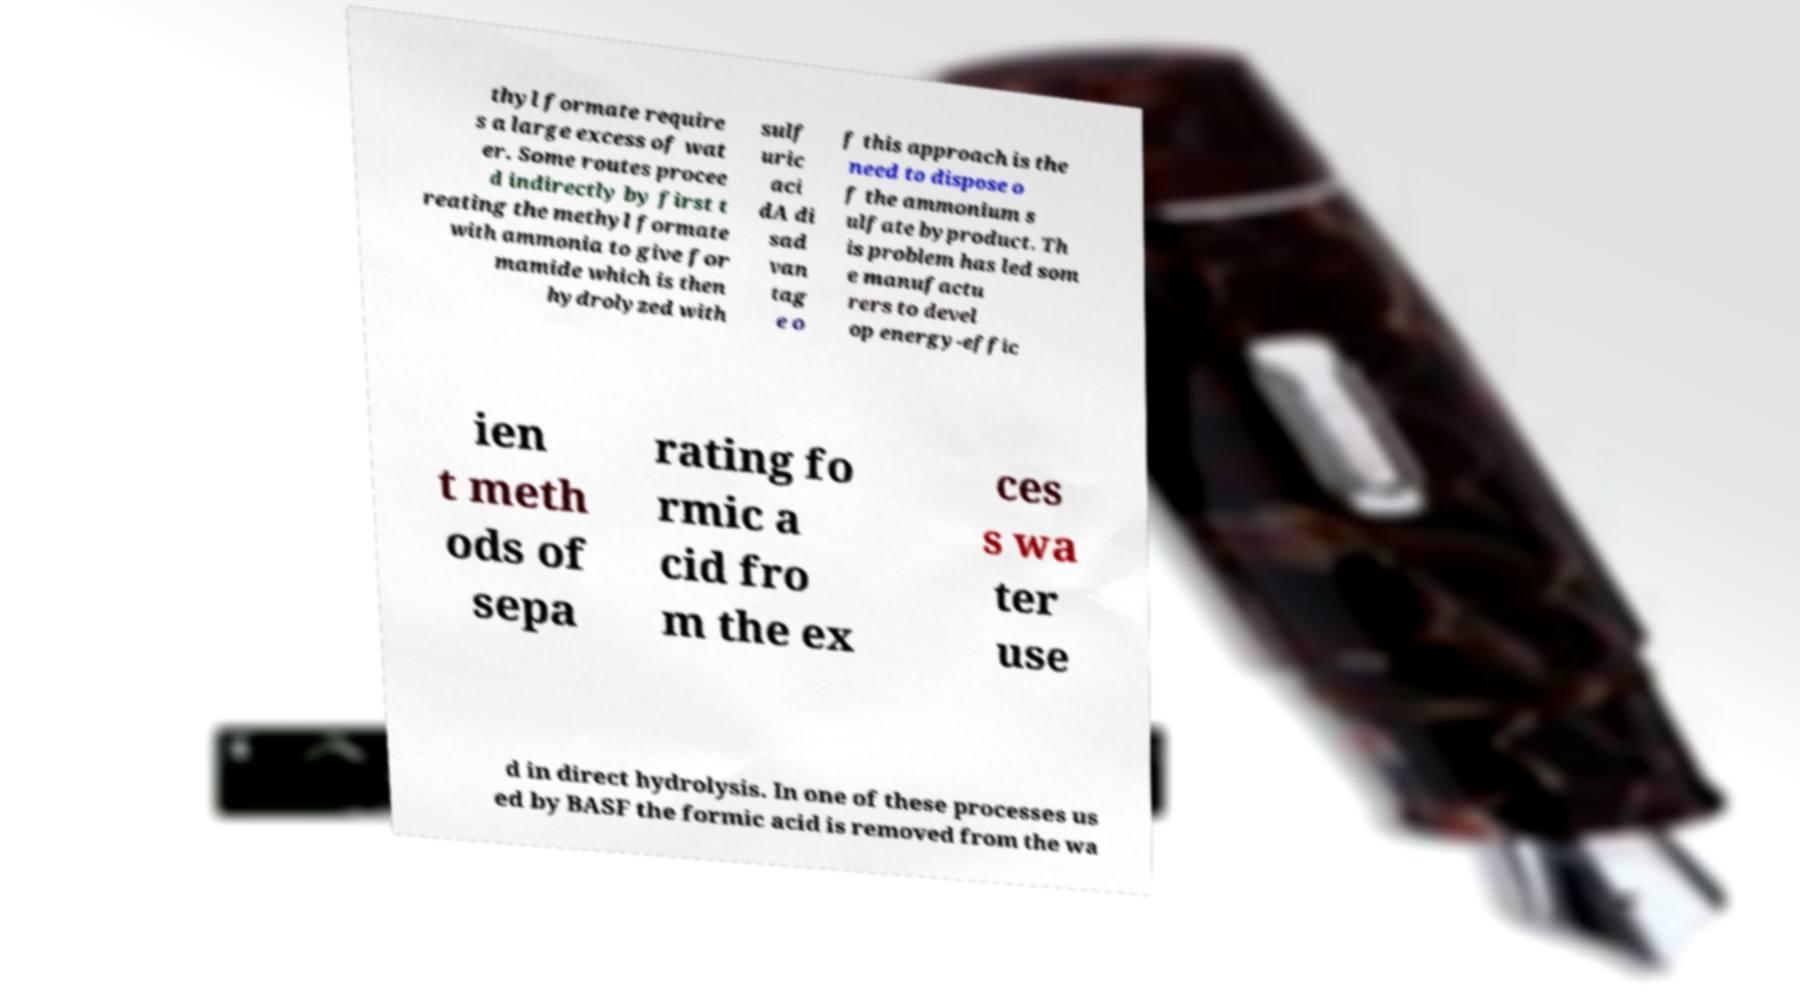Can you read and provide the text displayed in the image?This photo seems to have some interesting text. Can you extract and type it out for me? thyl formate require s a large excess of wat er. Some routes procee d indirectly by first t reating the methyl formate with ammonia to give for mamide which is then hydrolyzed with sulf uric aci dA di sad van tag e o f this approach is the need to dispose o f the ammonium s ulfate byproduct. Th is problem has led som e manufactu rers to devel op energy-effic ien t meth ods of sepa rating fo rmic a cid fro m the ex ces s wa ter use d in direct hydrolysis. In one of these processes us ed by BASF the formic acid is removed from the wa 